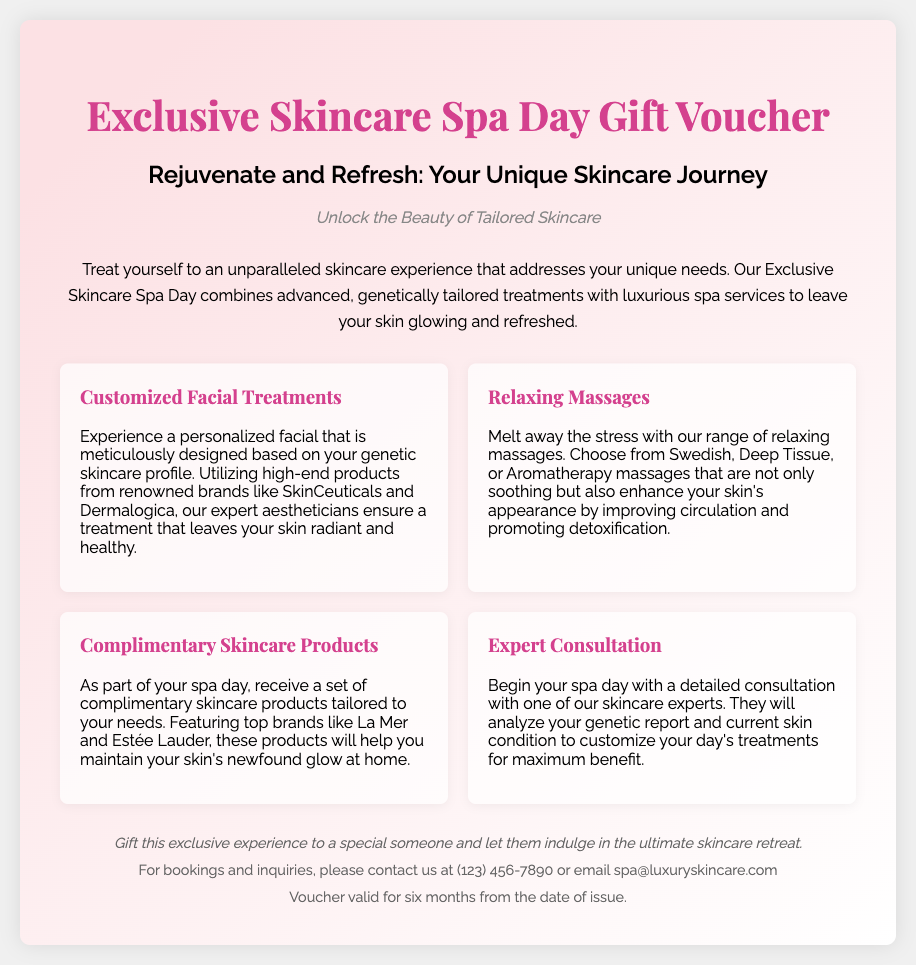What is the title of the voucher? The title of the voucher is mentioned prominently at the top of the document, which is "Exclusive Skincare Spa Day Gift Voucher."
Answer: Exclusive Skincare Spa Day Gift Voucher What treatments are included in the spa experience? The document lists various treatments, including customized facial treatments, relaxing massages, complimentary skincare products, and expert consultation.
Answer: Customized Facial Treatments, Relaxing Massages, Complimentary Skincare Products, Expert Consultation How long is the voucher valid for? The validity period of the voucher is stated in the footer section of the document, indicating it is valid for six months from the date of issue.
Answer: Six months What types of massages are offered? The document provides specific types of massages available during the spa day, which include Swedish, Deep Tissue, and Aromatherapy massages.
Answer: Swedish, Deep Tissue, Aromatherapy What is the contact number for bookings? The contact number for bookings is included in the footer of the document, allowing users to reach out for inquiries.
Answer: (123) 456-7890 What brands are mentioned for skincare products? The document highlights specific high-end skincare brands used in the spa treatments, including SkinCeuticals, Dermalogica, La Mer, and Estée Lauder.
Answer: SkinCeuticals, Dermalogica, La Mer, Estée Lauder What is the main focus of the spa day experience? The primary focus of the spa day experience is to offer treatments tailored to individual skincare needs, emphasizing personalized care based on genetic profiles.
Answer: Unique skincare needs What should recipients do if they want to gift the voucher? The document suggests that this experience can be gifted, indicating an intention to share the spa experience with others.
Answer: Gift this exclusive experience What kind of consultation is included? The voucher includes a detailed consultation with a skincare expert to analyze the recipient's genetic report and current skin condition.
Answer: Expert Consultation 